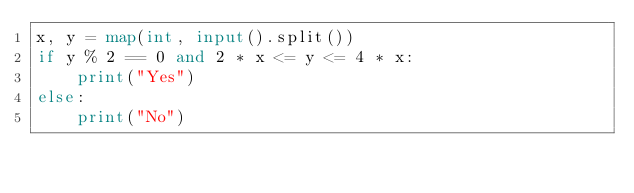Convert code to text. <code><loc_0><loc_0><loc_500><loc_500><_Python_>x, y = map(int, input().split())
if y % 2 == 0 and 2 * x <= y <= 4 * x:
    print("Yes")
else:
    print("No")</code> 